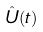Convert formula to latex. <formula><loc_0><loc_0><loc_500><loc_500>\hat { U } ( t )</formula> 